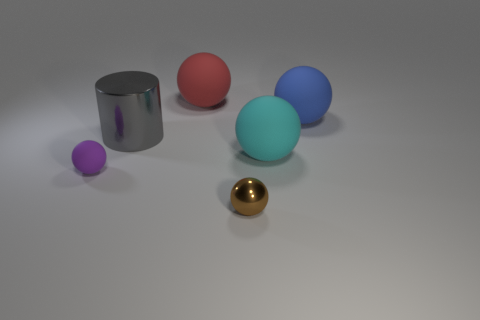Subtract all blue spheres. How many spheres are left? 4 Subtract all tiny brown metallic spheres. How many spheres are left? 4 Subtract 1 balls. How many balls are left? 4 Add 4 tiny purple matte things. How many objects exist? 10 Subtract all purple spheres. Subtract all gray blocks. How many spheres are left? 4 Subtract all balls. How many objects are left? 1 Subtract 0 gray balls. How many objects are left? 6 Subtract all tiny things. Subtract all tiny purple shiny balls. How many objects are left? 4 Add 5 big red objects. How many big red objects are left? 6 Add 1 large gray cylinders. How many large gray cylinders exist? 2 